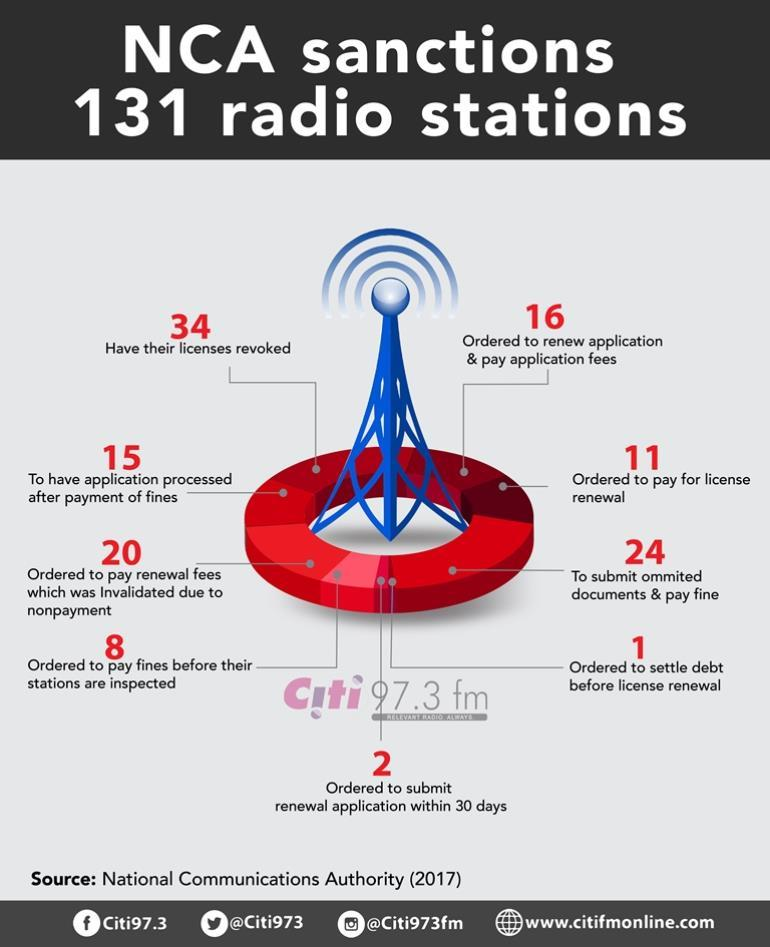Outline some significant characteristics in this image. In 2017, 24 radio stations were required to submit omitted documents and pay fines as per the National Communications Authority (NCA) regulations. In 2017, the National Communications Authority (NCA) ordered 11 radio stations to pay for their licenses. In 2017, the National Communications Authority (NCA) ordered 16 radio stations to renew their application and pay application fees. In 2017, the National Communications Authority (NCA) ordered at least one radio station to settle its debt before its license renewal. In 2017, a total of 34 radio stations had their licenses revoked by the National Communications Authority (NCA). 